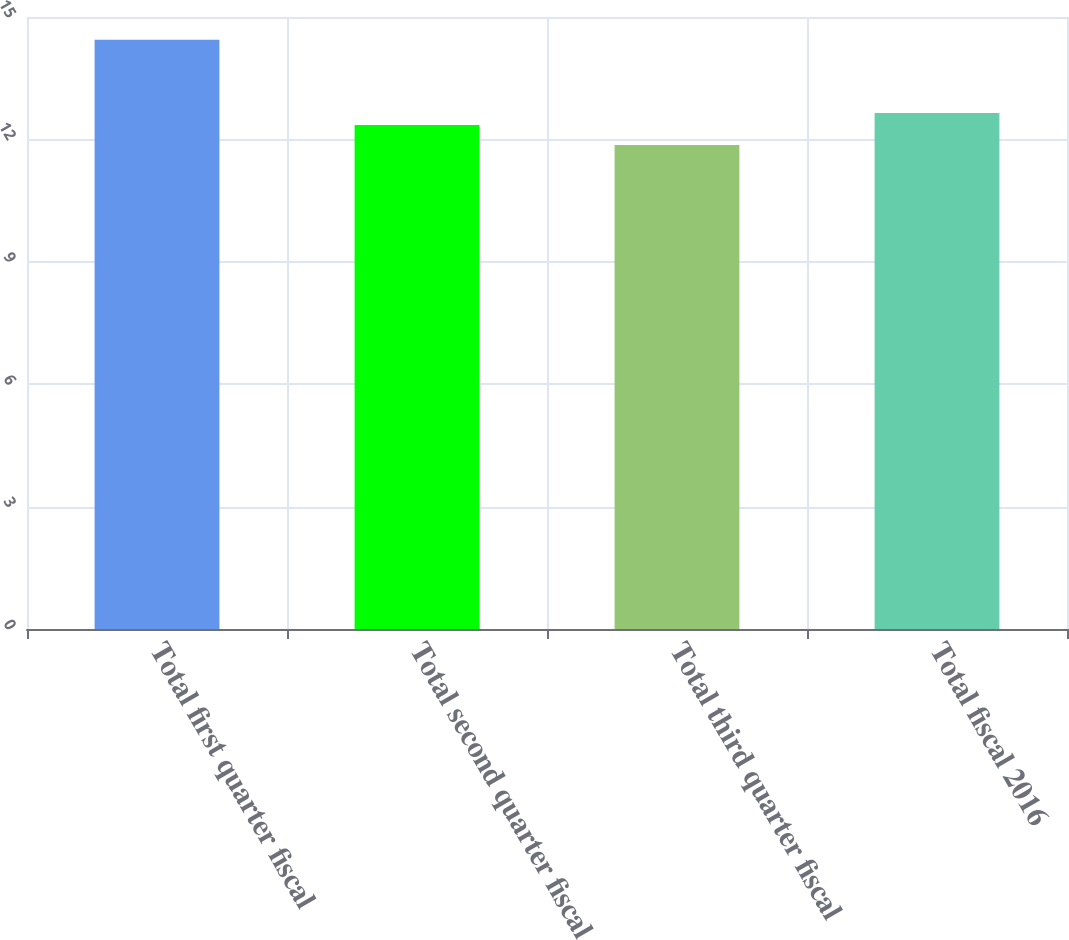Convert chart. <chart><loc_0><loc_0><loc_500><loc_500><bar_chart><fcel>Total first quarter fiscal<fcel>Total second quarter fiscal<fcel>Total third quarter fiscal<fcel>Total fiscal 2016<nl><fcel>14.44<fcel>12.35<fcel>11.86<fcel>12.65<nl></chart> 